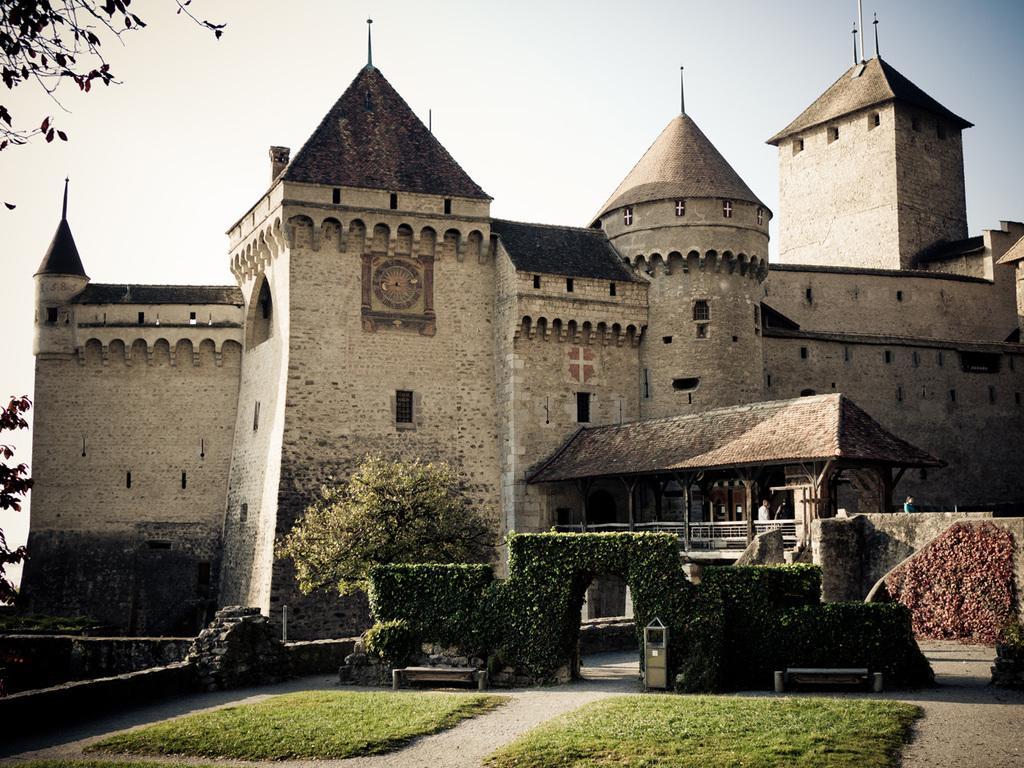In one or two sentences, can you explain what this image depicts? In the picture I can see a greenery ground,few plants,people and a building and there are few trees in the left corner. 